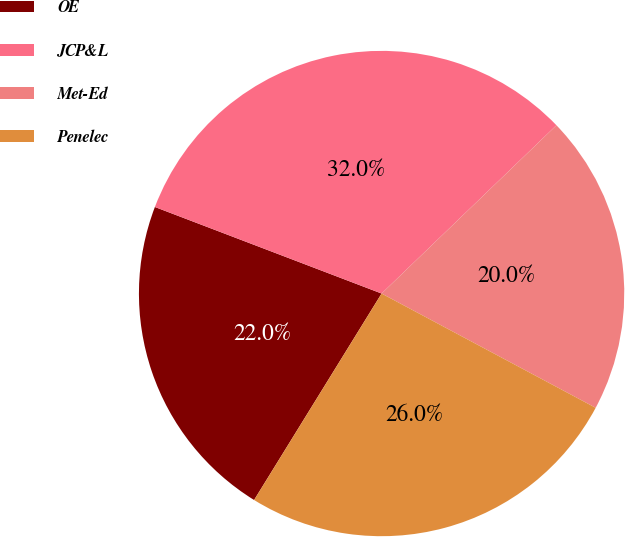Convert chart to OTSL. <chart><loc_0><loc_0><loc_500><loc_500><pie_chart><fcel>OE<fcel>JCP&L<fcel>Met-Ed<fcel>Penelec<nl><fcel>22.0%<fcel>32.0%<fcel>20.0%<fcel>26.0%<nl></chart> 